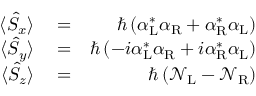<formula> <loc_0><loc_0><loc_500><loc_500>\begin{array} { r l r } { \langle \hat { S } _ { x } \rangle } & = } & { \hbar { \left } ( { \alpha } _ { L } ^ { * } { \alpha } _ { R } + { \alpha } _ { R } ^ { * } { \alpha } _ { L } \right ) } \\ { \langle \hat { S } _ { y } \rangle } & = } & { \hbar { \left } ( - i { \alpha } _ { L } ^ { * } { \alpha } _ { R } + i { \alpha } _ { R } ^ { * } { \alpha } _ { L } \right ) } \\ { \langle \hat { S } _ { z } \rangle } & = } & { \hbar { \left } ( { \mathcal { N } } _ { L } - { \mathcal { N } } _ { R } \right ) } \end{array}</formula> 